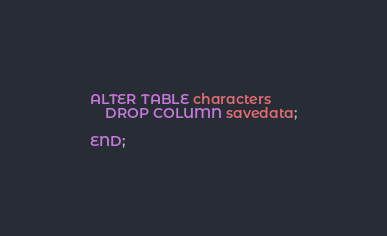Convert code to text. <code><loc_0><loc_0><loc_500><loc_500><_SQL_>ALTER TABLE characters
    DROP COLUMN savedata;

END;</code> 